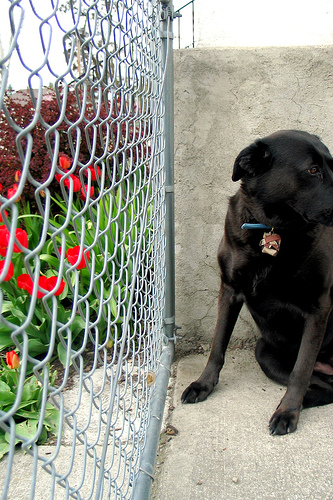<image>
Is there a dog in the wire? No. The dog is not contained within the wire. These objects have a different spatial relationship. 